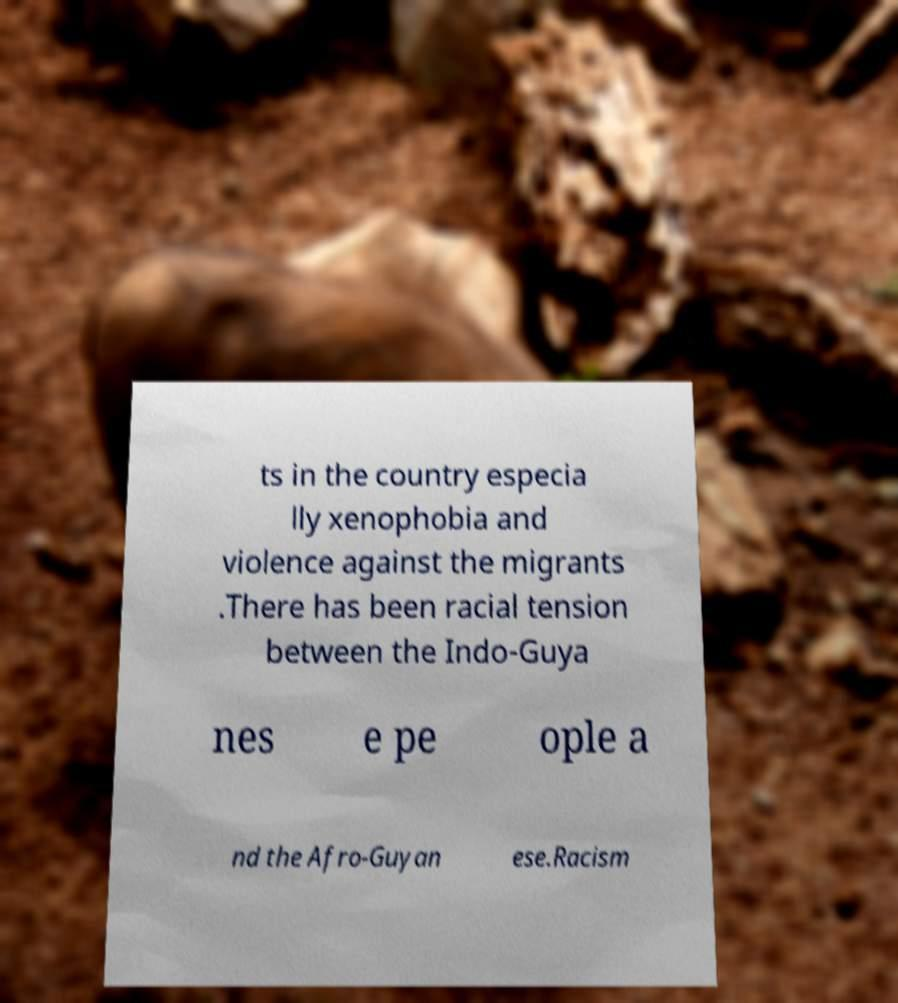What messages or text are displayed in this image? I need them in a readable, typed format. ts in the country especia lly xenophobia and violence against the migrants .There has been racial tension between the Indo-Guya nes e pe ople a nd the Afro-Guyan ese.Racism 